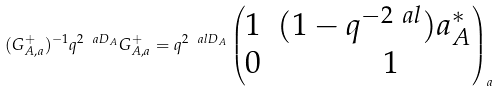<formula> <loc_0><loc_0><loc_500><loc_500>( G ^ { + } _ { A , a } ) ^ { - 1 } q ^ { 2 \ a D _ { A } } G ^ { + } _ { A , a } = q ^ { 2 \ a l D _ { A } } \begin{pmatrix} 1 & ( 1 - q ^ { - 2 \ a l } ) a ^ { \ast } _ { A } \\ 0 & \quad 1 \end{pmatrix} _ { a }</formula> 